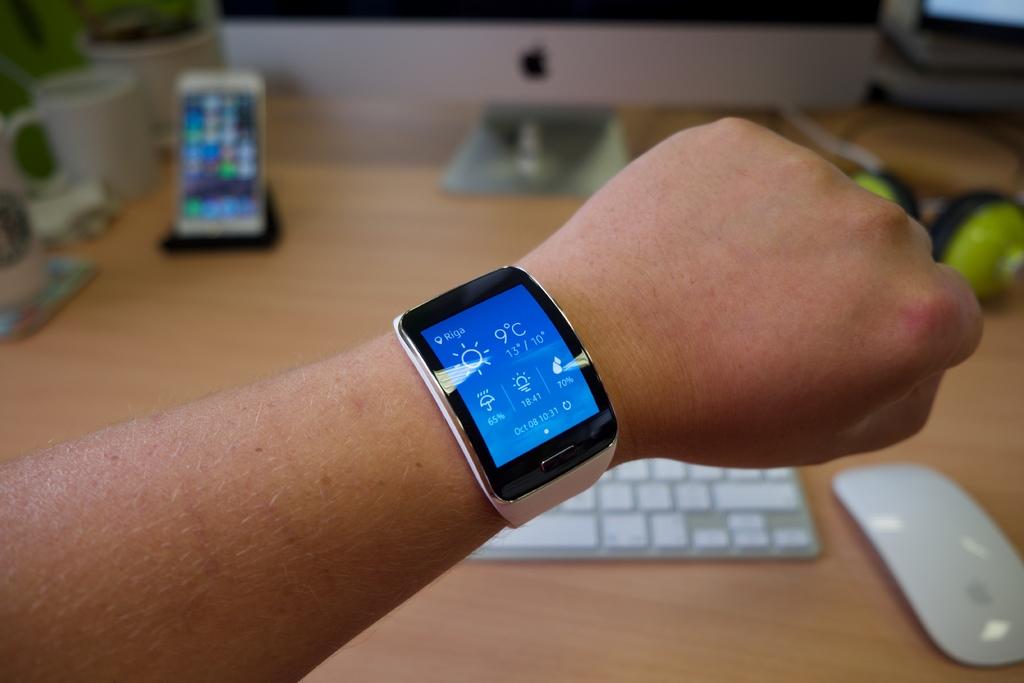What is the temperature?
Offer a very short reply. 9. 